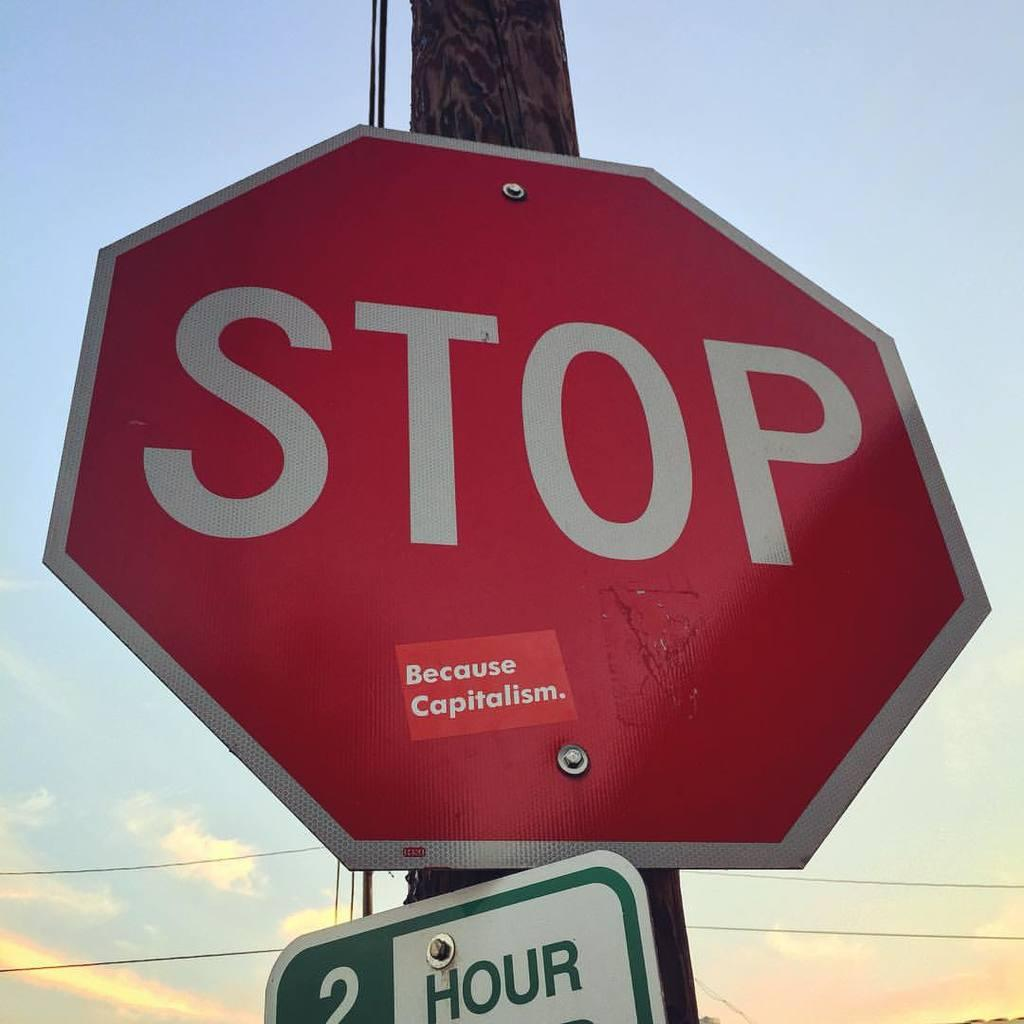<image>
Provide a brief description of the given image. A stop sign has a Because Capitalism sticker on it. 